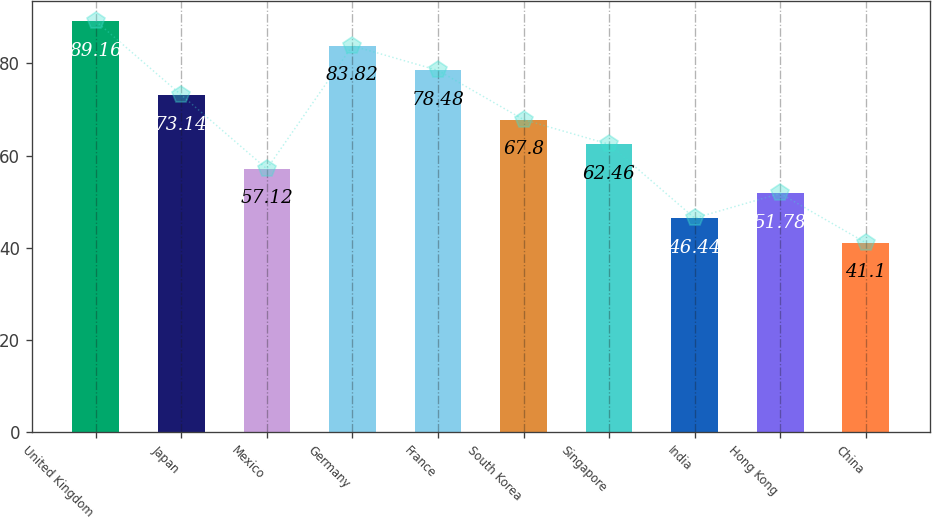<chart> <loc_0><loc_0><loc_500><loc_500><bar_chart><fcel>United Kingdom<fcel>Japan<fcel>Mexico<fcel>Germany<fcel>France<fcel>South Korea<fcel>Singapore<fcel>India<fcel>Hong Kong<fcel>China<nl><fcel>89.16<fcel>73.14<fcel>57.12<fcel>83.82<fcel>78.48<fcel>67.8<fcel>62.46<fcel>46.44<fcel>51.78<fcel>41.1<nl></chart> 